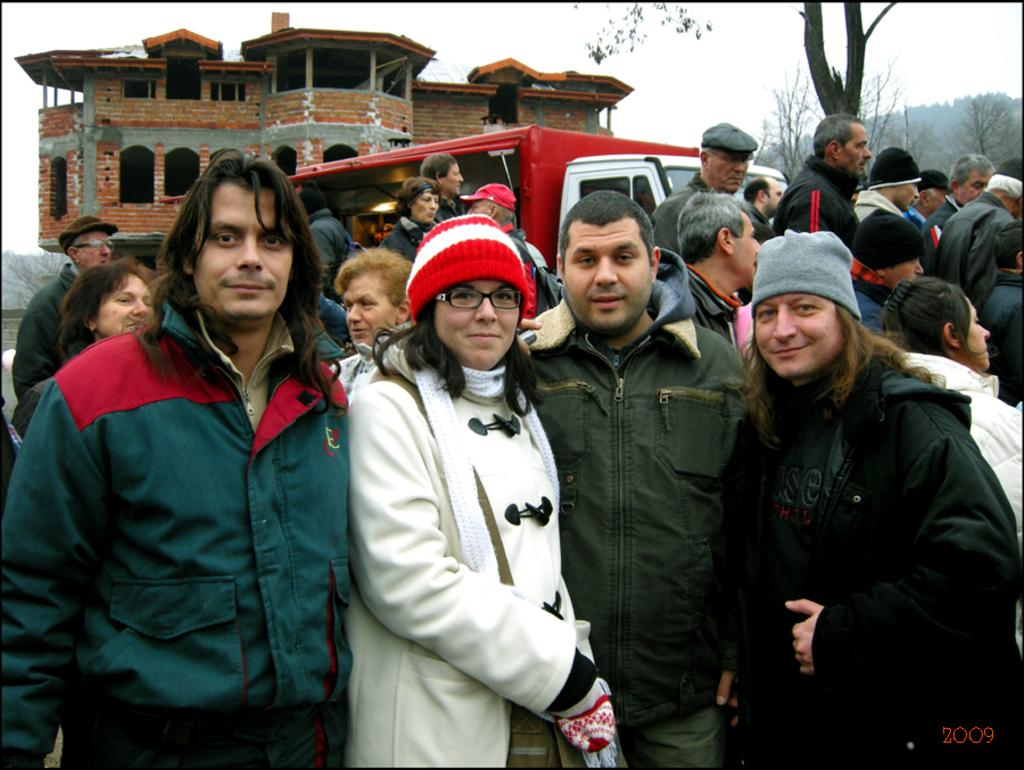What are the people in the image doing? The people in the image are standing and smiling. What can be seen in the background of the image? There is a food truck, a house, trees, and the sky visible in the background. What hobbies does the kitten have in the image? There is no kitten present in the image, so it is not possible to determine its hobbies. 